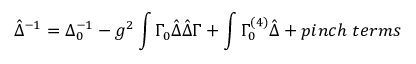Convert formula to latex. <formula><loc_0><loc_0><loc_500><loc_500>\hat { \Delta } ^ { - 1 } = \Delta _ { 0 } ^ { - 1 } - g ^ { 2 } \int \Gamma _ { 0 } \hat { \Delta } \hat { \Delta } \Gamma + \int \Gamma _ { 0 } ^ { ( 4 ) } \hat { \Delta } + p i n c h \, t e r m s</formula> 